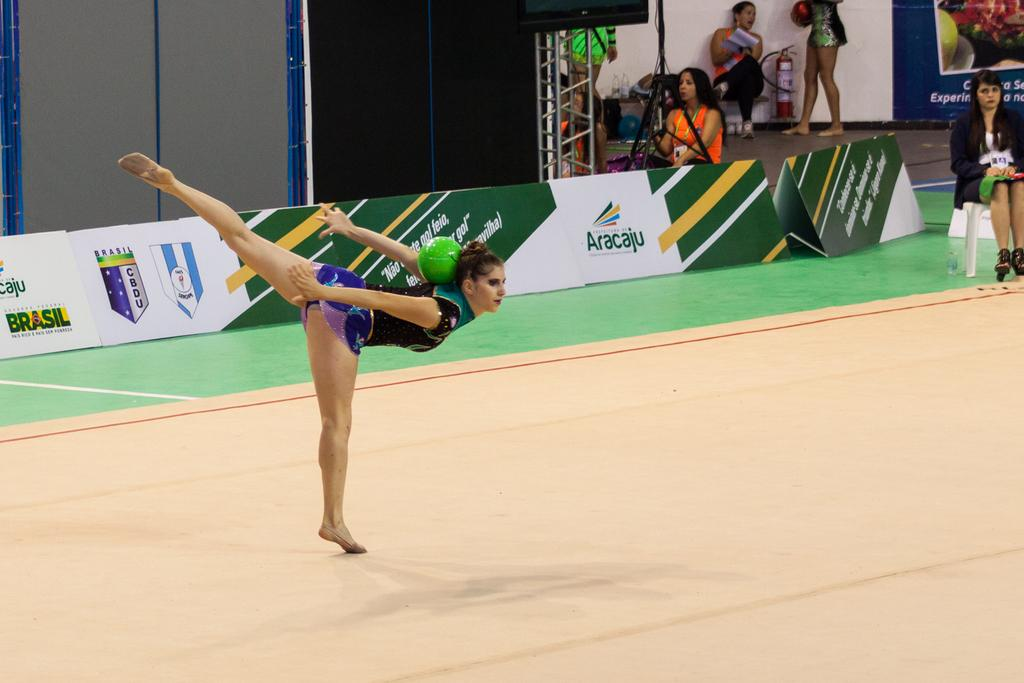<image>
Render a clear and concise summary of the photo. A gymnast performs a floor routine at the Aracaju games. 